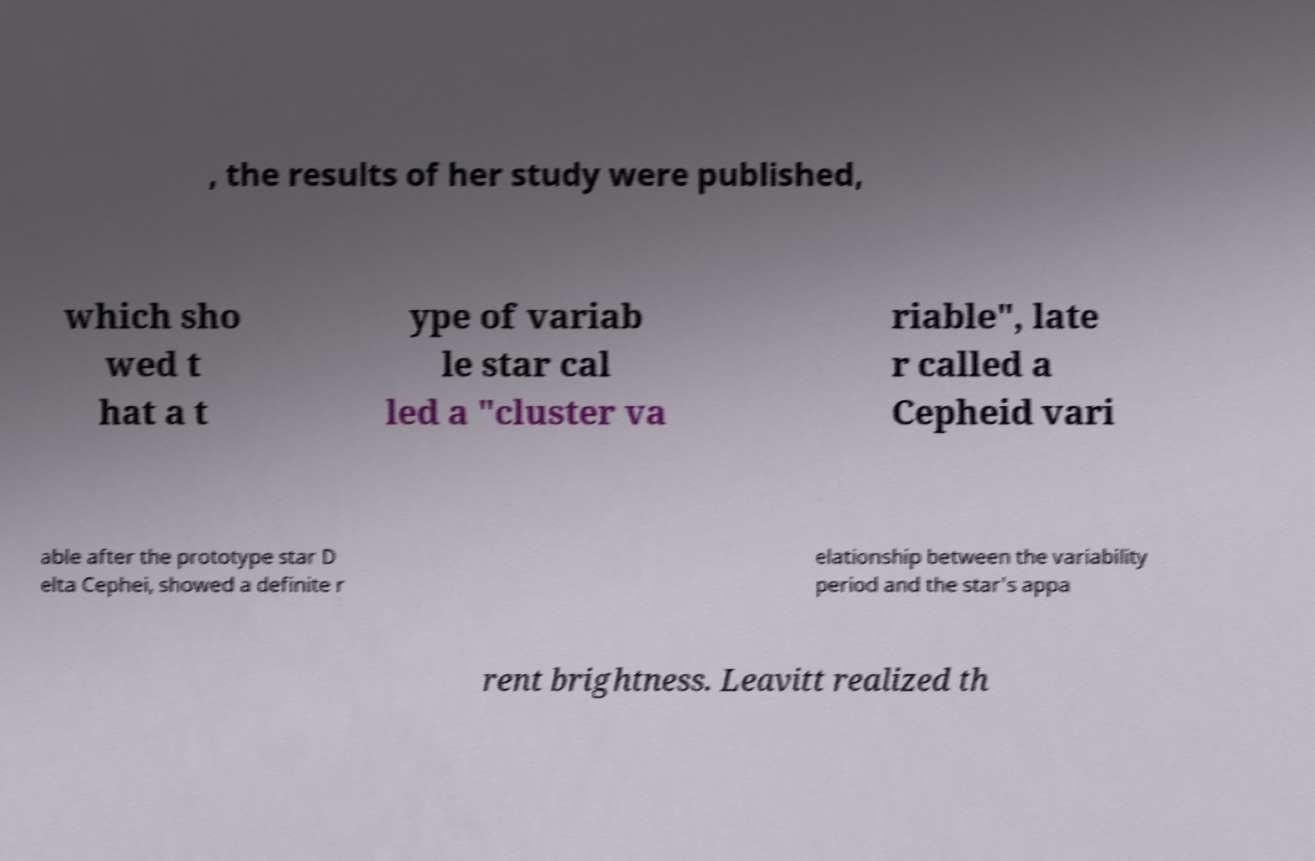Could you assist in decoding the text presented in this image and type it out clearly? , the results of her study were published, which sho wed t hat a t ype of variab le star cal led a "cluster va riable", late r called a Cepheid vari able after the prototype star D elta Cephei, showed a definite r elationship between the variability period and the star's appa rent brightness. Leavitt realized th 